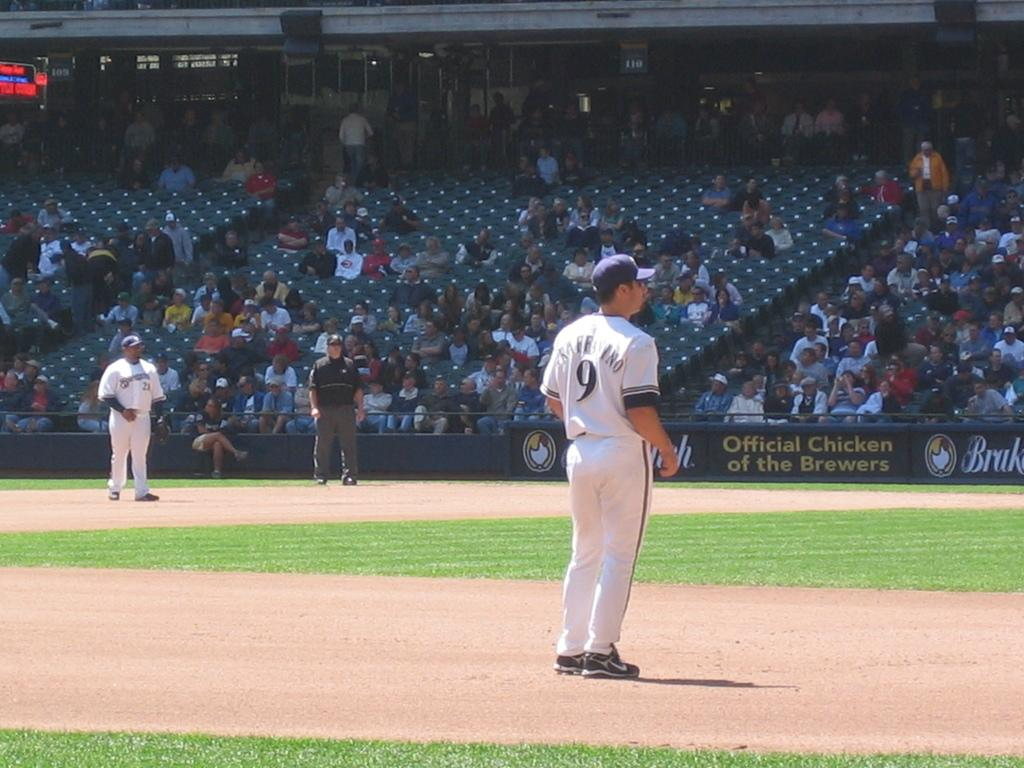<image>
Write a terse but informative summary of the picture. a baseball player with a 9 jersey waits on the field for a play 